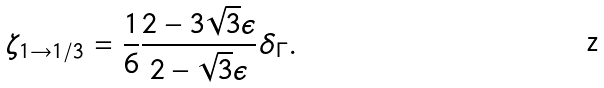<formula> <loc_0><loc_0><loc_500><loc_500>\zeta _ { 1 \to 1 / 3 } = \frac { 1 } { 6 } \frac { 2 - 3 \sqrt { 3 } \epsilon } { 2 - \sqrt { 3 } \epsilon } \delta _ { \Gamma } .</formula> 